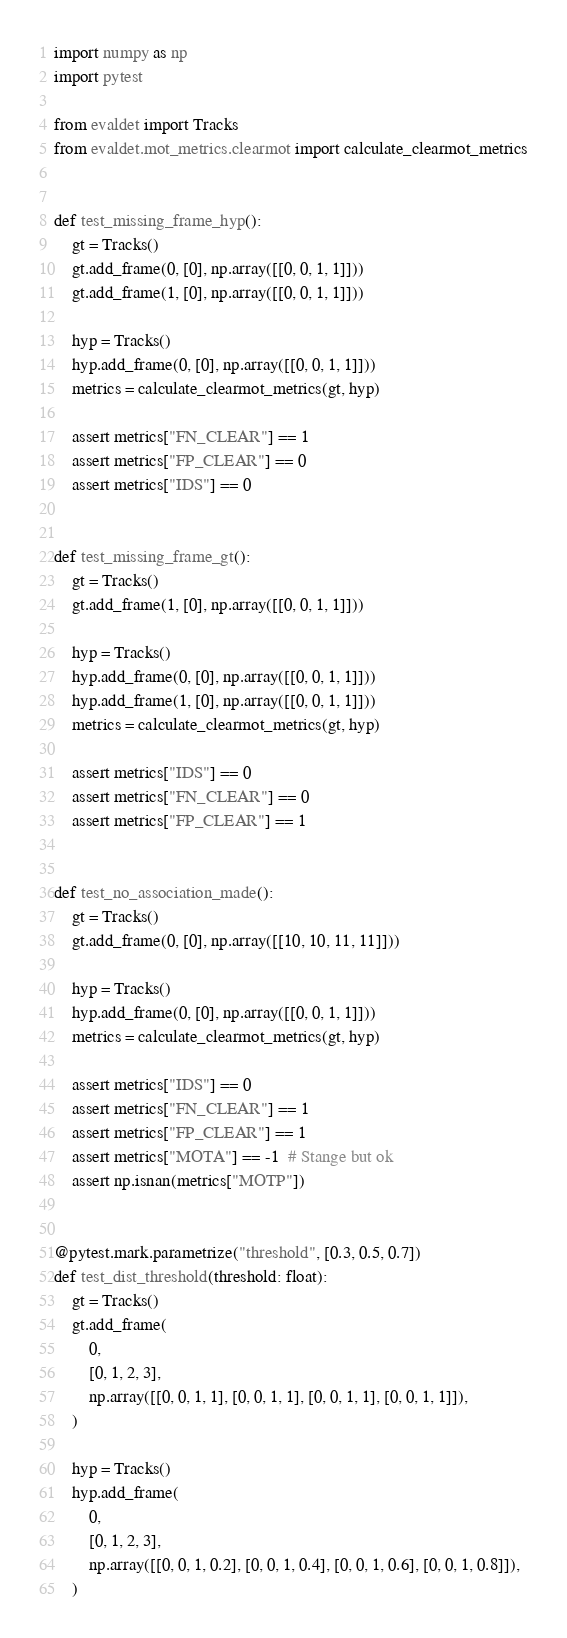<code> <loc_0><loc_0><loc_500><loc_500><_Python_>import numpy as np
import pytest

from evaldet import Tracks
from evaldet.mot_metrics.clearmot import calculate_clearmot_metrics


def test_missing_frame_hyp():
    gt = Tracks()
    gt.add_frame(0, [0], np.array([[0, 0, 1, 1]]))
    gt.add_frame(1, [0], np.array([[0, 0, 1, 1]]))

    hyp = Tracks()
    hyp.add_frame(0, [0], np.array([[0, 0, 1, 1]]))
    metrics = calculate_clearmot_metrics(gt, hyp)

    assert metrics["FN_CLEAR"] == 1
    assert metrics["FP_CLEAR"] == 0
    assert metrics["IDS"] == 0


def test_missing_frame_gt():
    gt = Tracks()
    gt.add_frame(1, [0], np.array([[0, 0, 1, 1]]))

    hyp = Tracks()
    hyp.add_frame(0, [0], np.array([[0, 0, 1, 1]]))
    hyp.add_frame(1, [0], np.array([[0, 0, 1, 1]]))
    metrics = calculate_clearmot_metrics(gt, hyp)

    assert metrics["IDS"] == 0
    assert metrics["FN_CLEAR"] == 0
    assert metrics["FP_CLEAR"] == 1


def test_no_association_made():
    gt = Tracks()
    gt.add_frame(0, [0], np.array([[10, 10, 11, 11]]))

    hyp = Tracks()
    hyp.add_frame(0, [0], np.array([[0, 0, 1, 1]]))
    metrics = calculate_clearmot_metrics(gt, hyp)

    assert metrics["IDS"] == 0
    assert metrics["FN_CLEAR"] == 1
    assert metrics["FP_CLEAR"] == 1
    assert metrics["MOTA"] == -1  # Stange but ok
    assert np.isnan(metrics["MOTP"])


@pytest.mark.parametrize("threshold", [0.3, 0.5, 0.7])
def test_dist_threshold(threshold: float):
    gt = Tracks()
    gt.add_frame(
        0,
        [0, 1, 2, 3],
        np.array([[0, 0, 1, 1], [0, 0, 1, 1], [0, 0, 1, 1], [0, 0, 1, 1]]),
    )

    hyp = Tracks()
    hyp.add_frame(
        0,
        [0, 1, 2, 3],
        np.array([[0, 0, 1, 0.2], [0, 0, 1, 0.4], [0, 0, 1, 0.6], [0, 0, 1, 0.8]]),
    )
</code> 